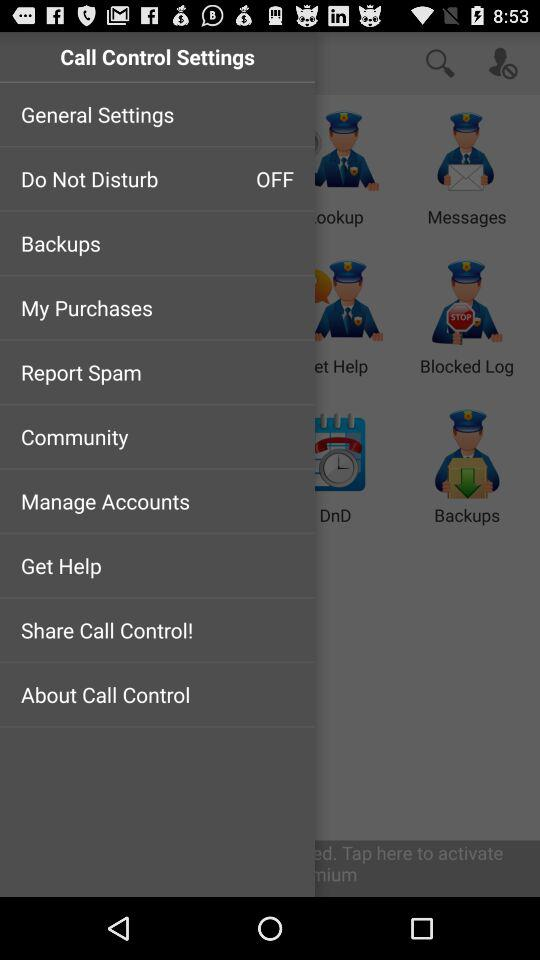What is the status of "Do Not Disturb"? The status of "Do Not Disturb" is "off". 